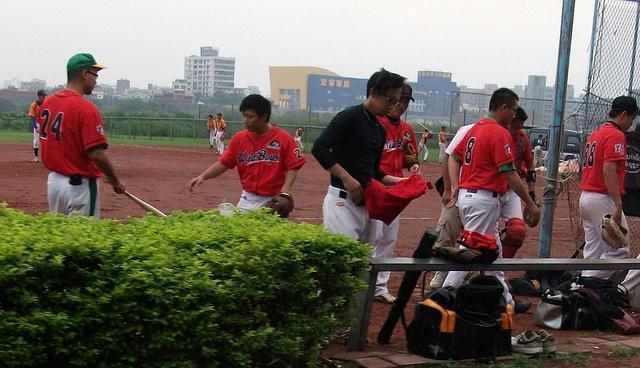How many backpacks can be seen?
Give a very brief answer. 3. How many people are there?
Give a very brief answer. 8. How many suitcases are visible?
Give a very brief answer. 1. 